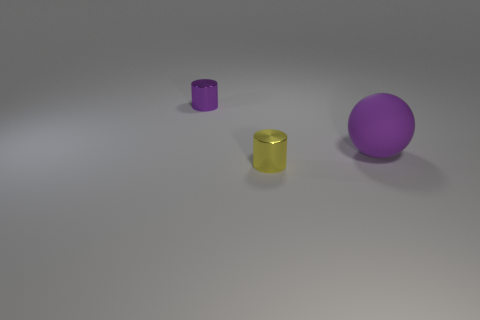Add 1 big red blocks. How many objects exist? 4 Subtract all yellow cylinders. How many cylinders are left? 1 Subtract 2 cylinders. How many cylinders are left? 0 Subtract all balls. How many objects are left? 2 Subtract all cyan spheres. Subtract all gray cubes. How many spheres are left? 1 Subtract all small cubes. Subtract all tiny shiny things. How many objects are left? 1 Add 2 metal objects. How many metal objects are left? 4 Add 3 large purple rubber cubes. How many large purple rubber cubes exist? 3 Subtract 0 gray balls. How many objects are left? 3 